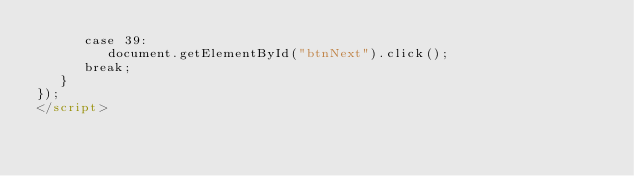Convert code to text. <code><loc_0><loc_0><loc_500><loc_500><_HTML_>      case 39:
         document.getElementById("btnNext").click();
      break;
   }
});
</script>
</code> 